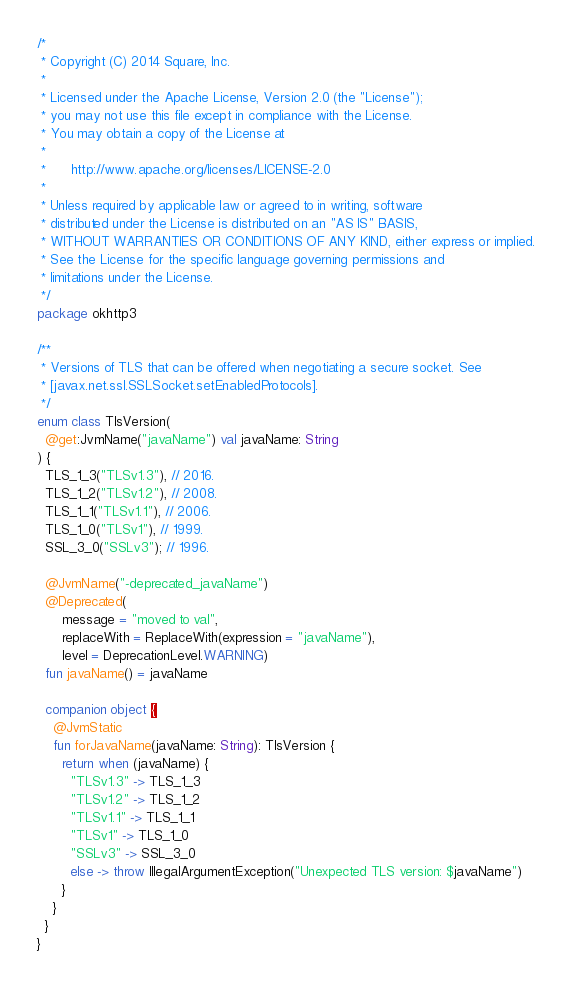Convert code to text. <code><loc_0><loc_0><loc_500><loc_500><_Kotlin_>/*
 * Copyright (C) 2014 Square, Inc.
 *
 * Licensed under the Apache License, Version 2.0 (the "License");
 * you may not use this file except in compliance with the License.
 * You may obtain a copy of the License at
 *
 *      http://www.apache.org/licenses/LICENSE-2.0
 *
 * Unless required by applicable law or agreed to in writing, software
 * distributed under the License is distributed on an "AS IS" BASIS,
 * WITHOUT WARRANTIES OR CONDITIONS OF ANY KIND, either express or implied.
 * See the License for the specific language governing permissions and
 * limitations under the License.
 */
package okhttp3

/**
 * Versions of TLS that can be offered when negotiating a secure socket. See
 * [javax.net.ssl.SSLSocket.setEnabledProtocols].
 */
enum class TlsVersion(
  @get:JvmName("javaName") val javaName: String
) {
  TLS_1_3("TLSv1.3"), // 2016.
  TLS_1_2("TLSv1.2"), // 2008.
  TLS_1_1("TLSv1.1"), // 2006.
  TLS_1_0("TLSv1"), // 1999.
  SSL_3_0("SSLv3"); // 1996.

  @JvmName("-deprecated_javaName")
  @Deprecated(
      message = "moved to val",
      replaceWith = ReplaceWith(expression = "javaName"),
      level = DeprecationLevel.WARNING)
  fun javaName() = javaName

  companion object {
    @JvmStatic
    fun forJavaName(javaName: String): TlsVersion {
      return when (javaName) {
        "TLSv1.3" -> TLS_1_3
        "TLSv1.2" -> TLS_1_2
        "TLSv1.1" -> TLS_1_1
        "TLSv1" -> TLS_1_0
        "SSLv3" -> SSL_3_0
        else -> throw IllegalArgumentException("Unexpected TLS version: $javaName")
      }
    }
  }
}
</code> 